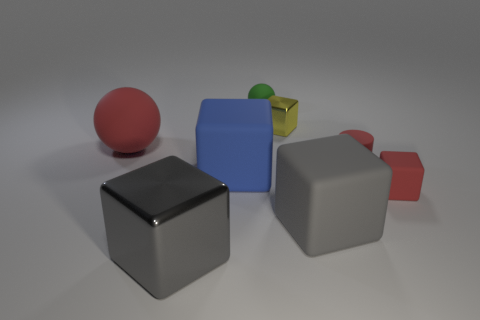What number of other objects are the same color as the small metal thing?
Keep it short and to the point. 0. Are there any other things that have the same size as the blue object?
Your response must be concise. Yes. What number of other objects are there of the same shape as the yellow thing?
Give a very brief answer. 4. Do the red cylinder and the gray matte thing have the same size?
Your answer should be compact. No. Is there a matte cylinder?
Provide a succinct answer. Yes. Is there any other thing that has the same material as the blue thing?
Offer a very short reply. Yes. Are there any green spheres that have the same material as the tiny yellow block?
Your answer should be compact. No. There is a red sphere that is the same size as the blue rubber block; what is its material?
Ensure brevity in your answer.  Rubber. How many rubber objects are the same shape as the large shiny object?
Your response must be concise. 3. What is the size of the other ball that is the same material as the green sphere?
Your response must be concise. Large. 